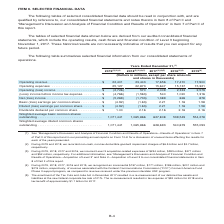According to Centurylink's financial document, What is the amount of incremental operating revenue earned in 2017? According to the financial document, $186 million. The relevant text states: "ognized an incremental $157 million, $171 million, $186 million, $201 million and $215 million, respectively, of revenue associated with the Federal Communications..." Also, What is the new federal corporate tax rate in 2017? According to the financial document, 21%. The relevant text states: "abilities at the new federal corporate tax rate of 21%. The re-measurement resulted in tax expense of $92 million for 2018 and a tax benefit of approximat..." Also, What types of expenses were recorded during 2018? The document contains multiple relevant values: non-cash, non-tax-deductible goodwill impairment charges, Level 3 acquisition-related expenses, tax expense. From the document: "(2) During 2019 and 2018, we recorded non-cash, non-tax-deductible goodwill impairment charges of $6.5 billion and $2.7 billion, respectively. (3) Dur..." Also, can you calculate: What is the sum of non-cash, non-tax-deductible goodwill impairment charges for 2019 and 2018? Based on the calculation: $6.5 billion + $2.7 billion , the result is 9.2 (in billions). This is based on the information: "goodwill impairment charges of $6.5 billion and $2.7 billion, respectively. on-tax-deductible goodwill impairment charges of $6.5 billion and $2.7 billion, respectively...." The key data points involved are: 2.7, 6.5. Additionally, Which year has the lowest operating expenses? According to the financial document, 2016. The relevant text states: "2019 (2)(3)(4) 2018 (2)(3)(4)(5) 2017 (3)(4)(5) 2016 (3)(4) 2015 (4)..." Also, can you calculate: What is the average non-cash, non-tax-deductible goodwill impairment charge in 2018 and 2019? To answer this question, I need to perform calculations using the financial data. The calculation is: (6.5+2.7)/2, which equals 4.6 (in billions). This is based on the information: "goodwill impairment charges of $6.5 billion and $2.7 billion, respectively. on-tax-deductible goodwill impairment charges of $6.5 billion and $2.7 billion, respectively...." The key data points involved are: 2.7, 6.5. 